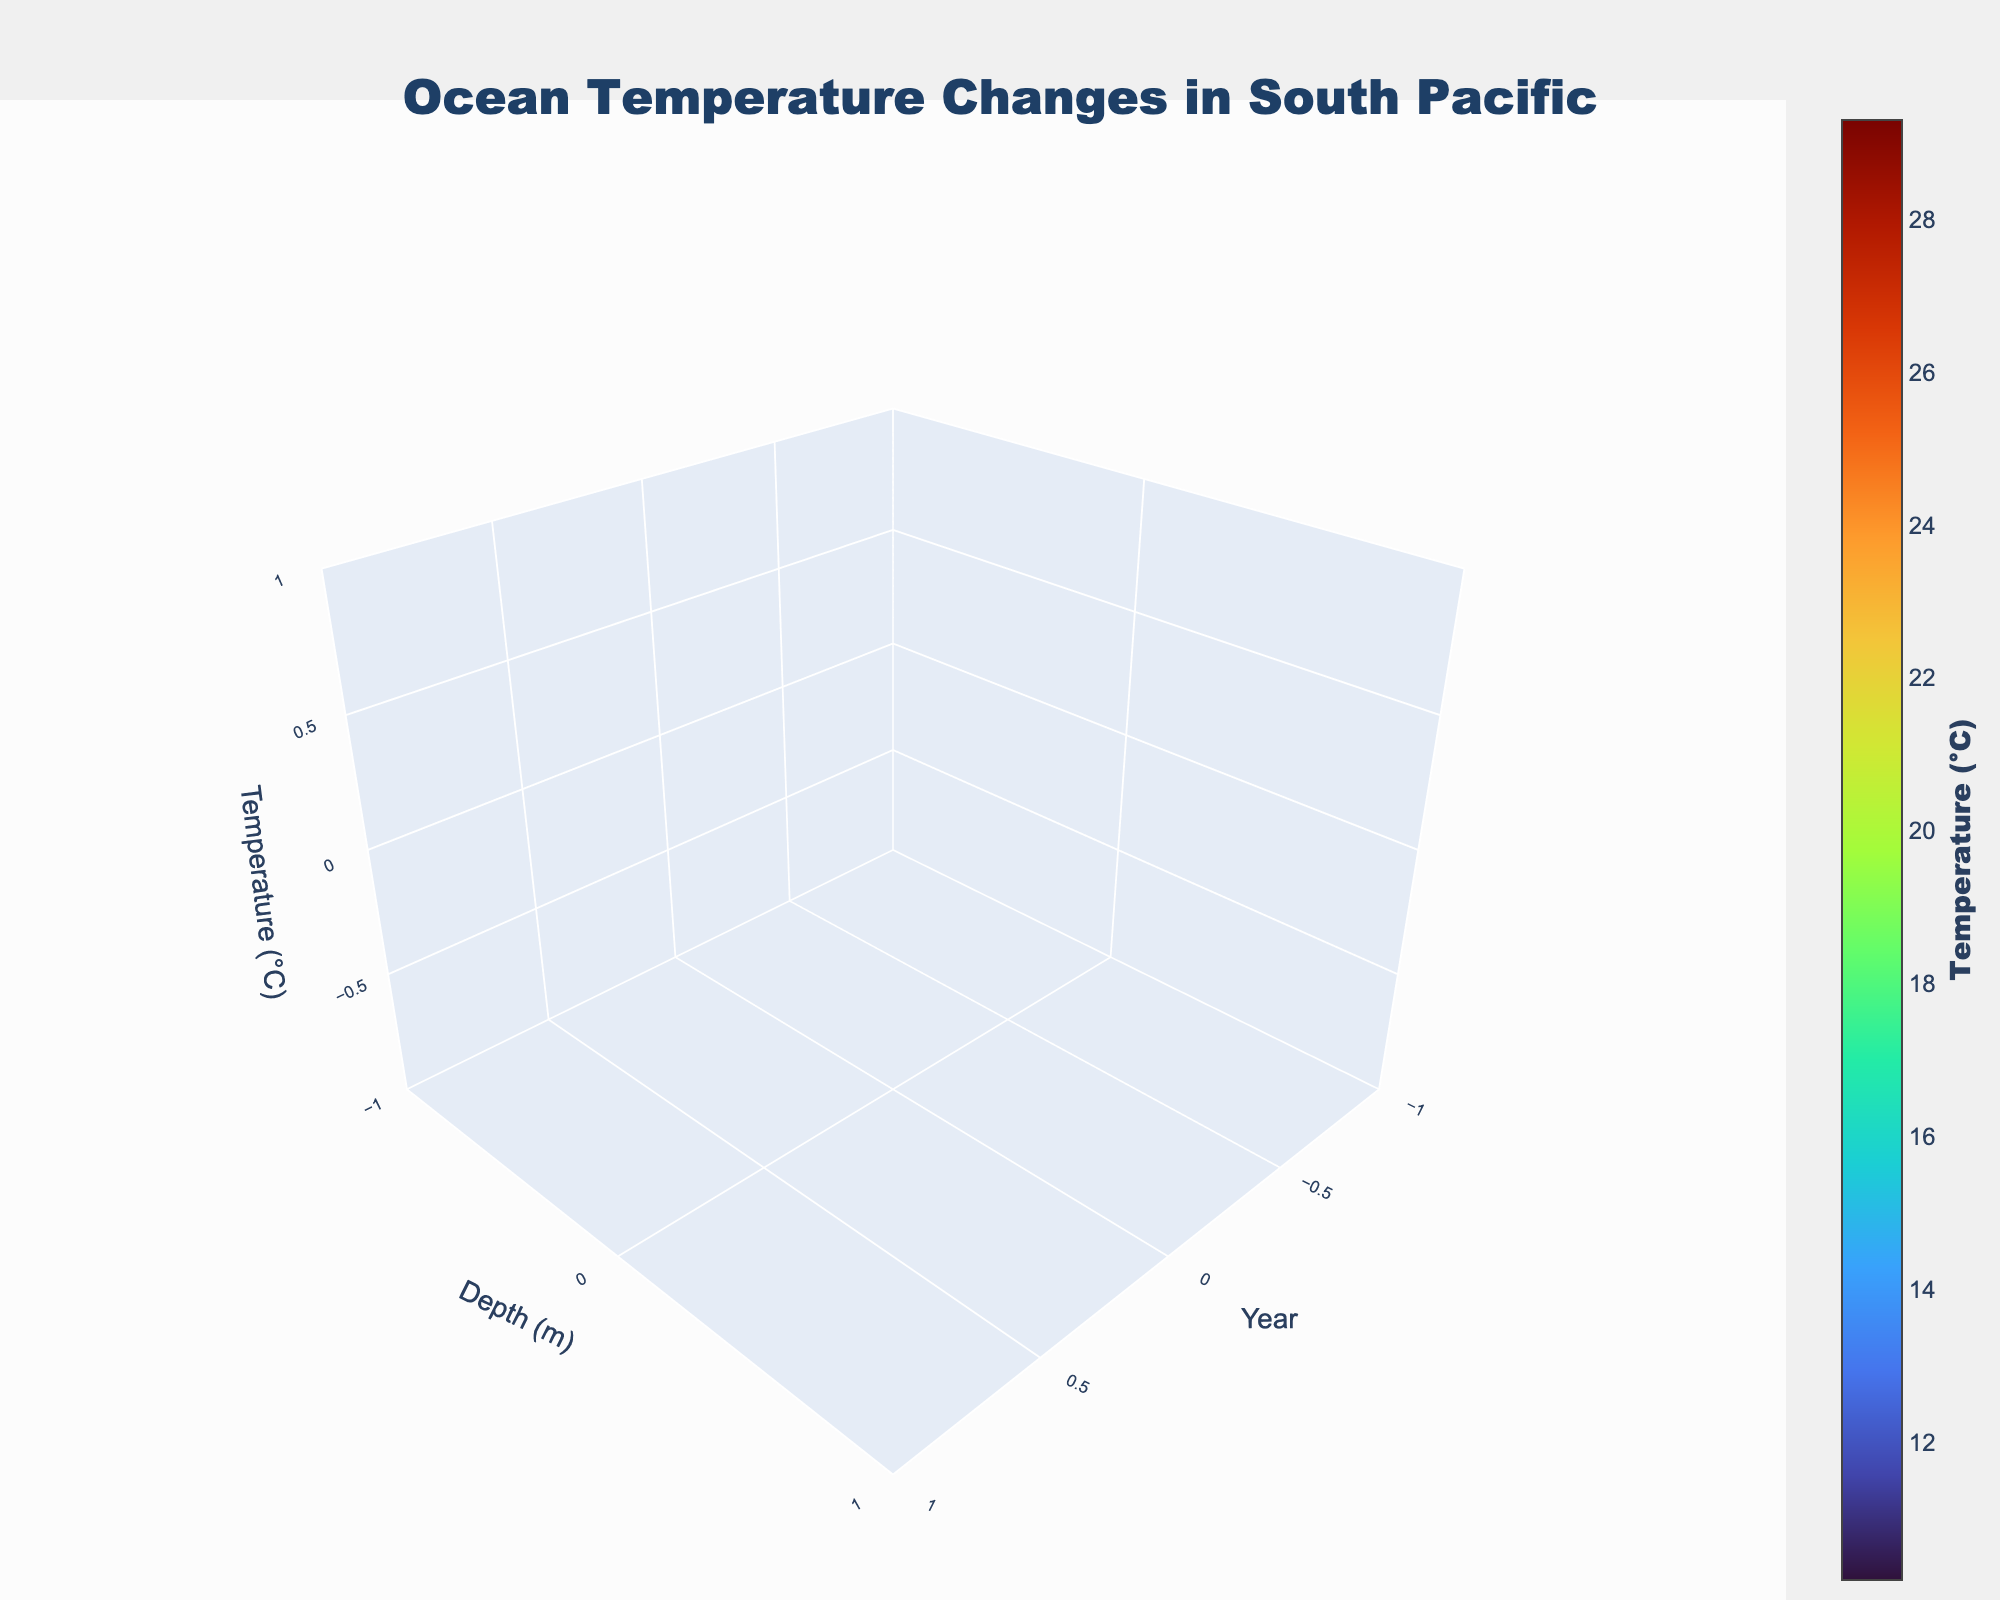What is the title of the figure? The title of the figure is displayed prominently at the top of the plot. It is formatted in a large, bold font to ensure it stands out.
Answer: Ocean Temperature Changes in South Pacific What are the axis labels in the figure? The axis labels provide essential information about the dimensions of the plot. The x-axis is labeled 'Year,' the y-axis is labeled 'Depth (m),' and the z-axis is labeled 'Temperature (°C).'
Answer: Year, Depth (m), Temperature (°C) What is the range of depths covered in the plot? The plot covers depths ranging from 0 meters (surface) to 1000 meters. This is evident from the y-axis labels that indicate the depth values.
Answer: 0 to 1000 meters What is the temperature at the surface (0 m) in the year 2020? To find this, locate the point at year 2020 along the x-axis and depth 0 meters along the y-axis, then read the temperature value from the z-axis or colorbar.
Answer: 29.3°C Which year shows the highest temperature at the depth of 500 meters? Check the temperature values at 500 meters depth across all years. The year with the highest value will be the one with the greatest temperature reading.
Answer: 2020 How has the temperature at 100 meters depth changed from 1990 to 2020? Identify the temperature values at 100 meters depth for the years 1990 and 2020, then calculate the difference to determine the change over time.
Answer: Increased by 0.8°C (from 25.1°C to 25.9°C) What is the average surface temperature across all the years represented in the plot? Sum the surface temperatures for the years 1990, 2000, 2010, and 2020, then divide by the number of years to find the average.
Answer: 28.725°C Is there a noticeable trend in temperature changes with depth over time? Examine the plot to see if the temperature values increase or decrease with depth over the given years and whether there's a consistent pattern over time.
Answer: Temperatures generally decrease with depth, and there is a slight warming trend over the years Which depth shows the least change in temperature from 1990 to 2020? Compare the temperature values for each depth at the years 1990 and 2020 and identify the depth with the smallest temperature difference.
Answer: 1000 meters Does the color scheme of the plot help in understanding temperature variations, and how? The Turbo colorscale maps temperature variations to different colors, making it easier to distinguish between high and low temperatures visually. Higher temperatures are represented by warmer colors and lower temperatures by cooler colors.
Answer: Yes, it helps visualize temperature differences easily 